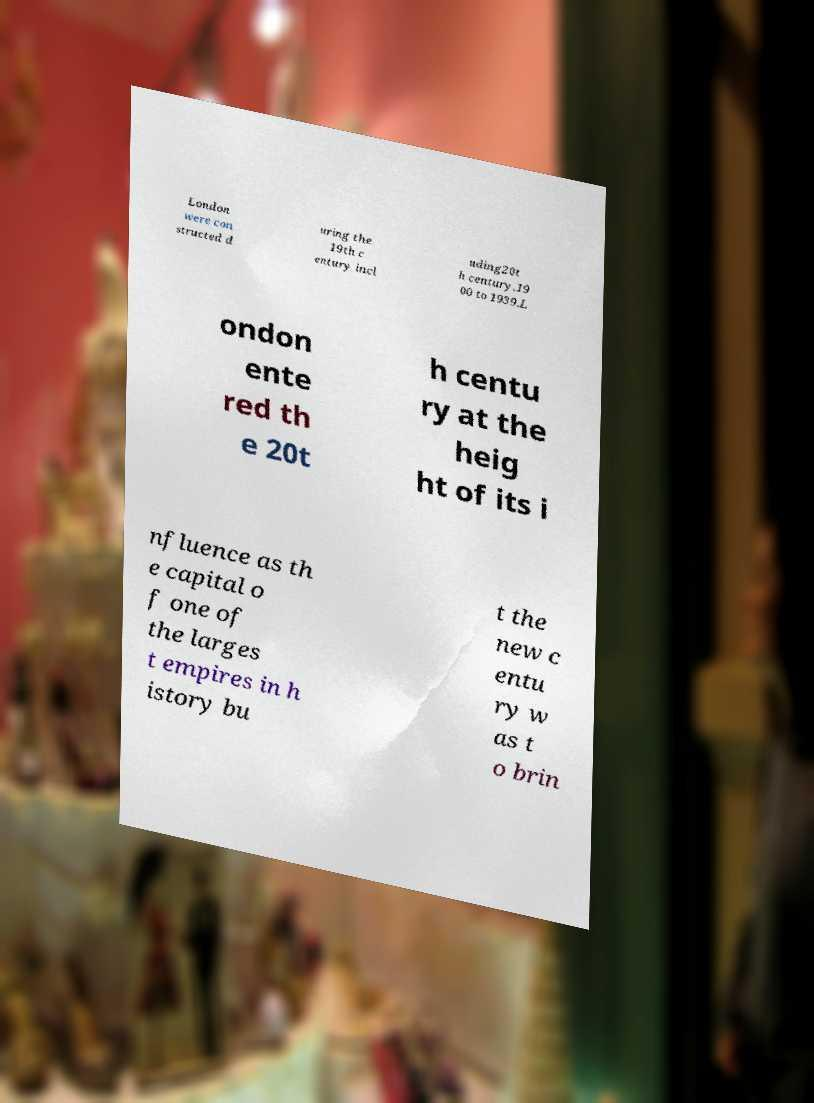Can you read and provide the text displayed in the image?This photo seems to have some interesting text. Can you extract and type it out for me? London were con structed d uring the 19th c entury incl uding20t h century.19 00 to 1939.L ondon ente red th e 20t h centu ry at the heig ht of its i nfluence as th e capital o f one of the larges t empires in h istory bu t the new c entu ry w as t o brin 